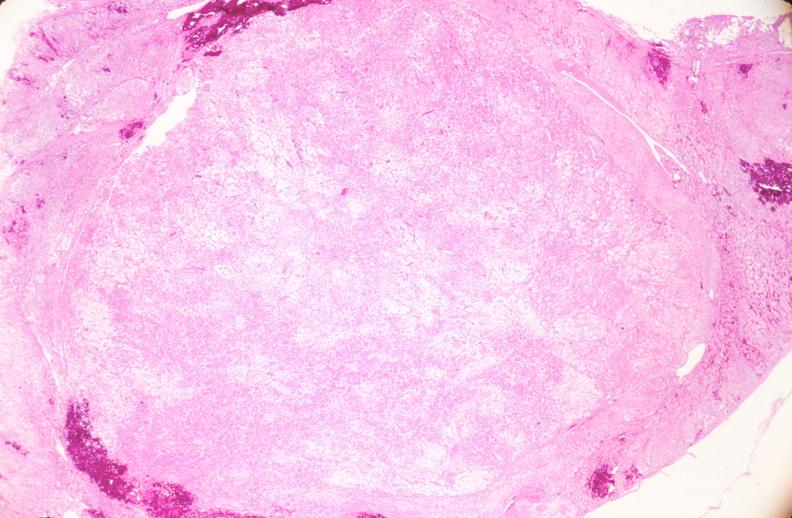what does this image show?
Answer the question using a single word or phrase. Uterus 